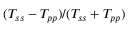<formula> <loc_0><loc_0><loc_500><loc_500>( T _ { s s } - T _ { p p } ) / ( T _ { s s } + T _ { p p } )</formula> 